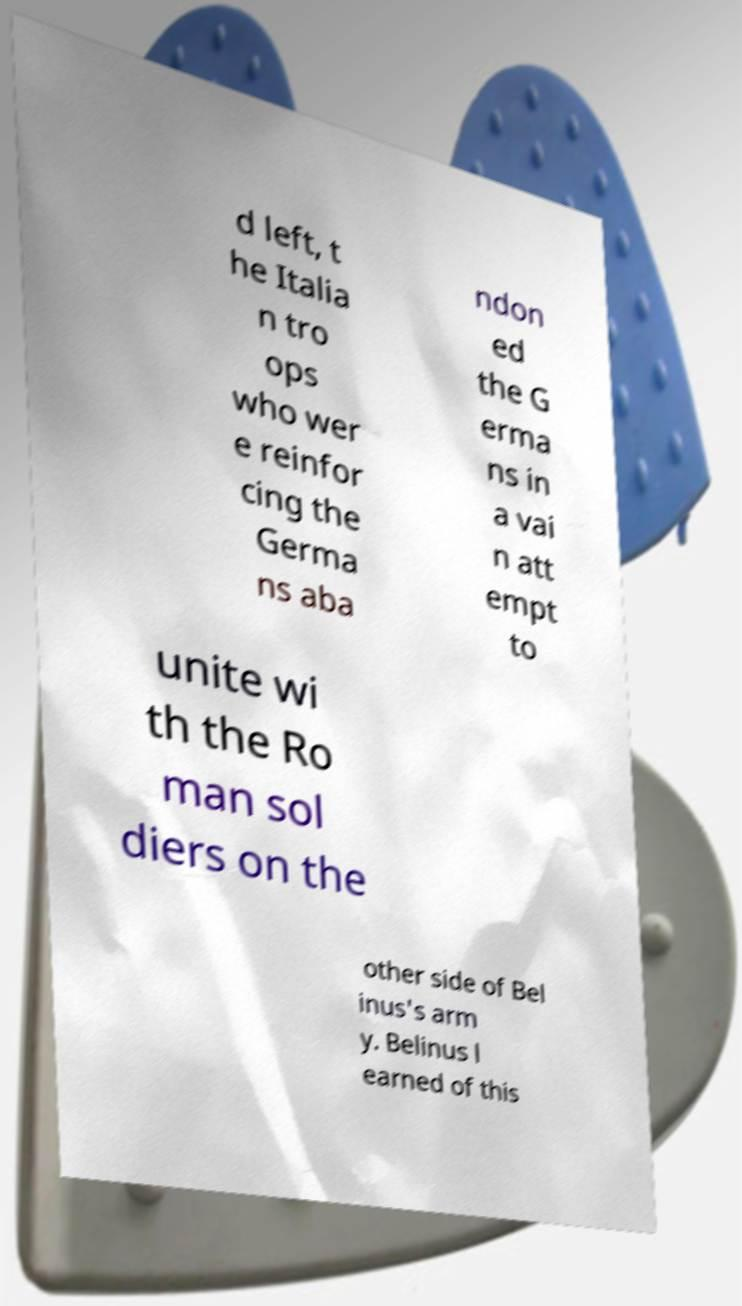Can you read and provide the text displayed in the image?This photo seems to have some interesting text. Can you extract and type it out for me? d left, t he Italia n tro ops who wer e reinfor cing the Germa ns aba ndon ed the G erma ns in a vai n att empt to unite wi th the Ro man sol diers on the other side of Bel inus's arm y. Belinus l earned of this 